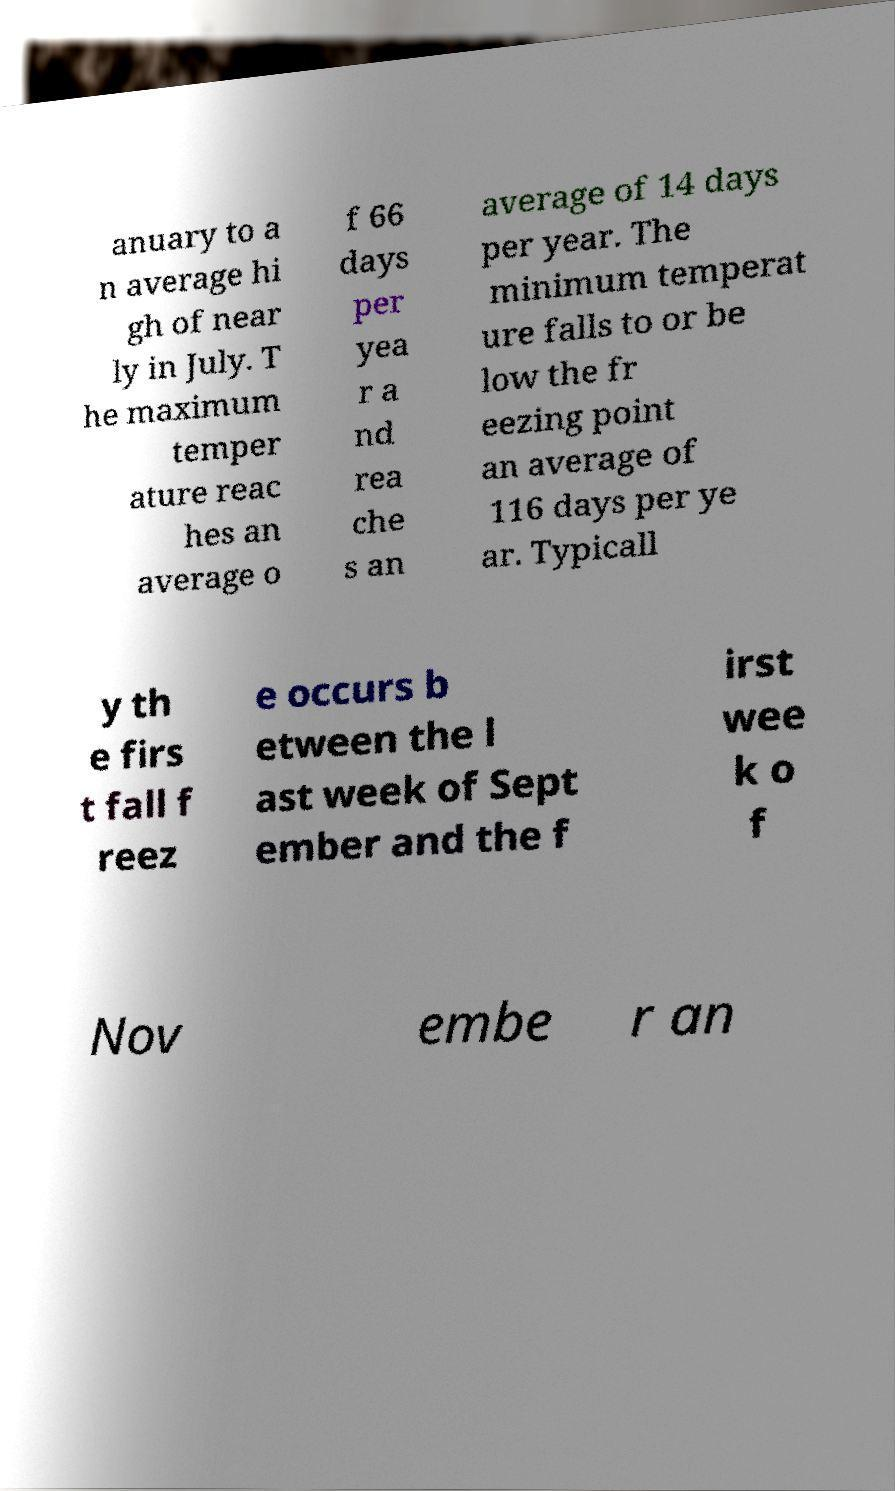For documentation purposes, I need the text within this image transcribed. Could you provide that? anuary to a n average hi gh of near ly in July. T he maximum temper ature reac hes an average o f 66 days per yea r a nd rea che s an average of 14 days per year. The minimum temperat ure falls to or be low the fr eezing point an average of 116 days per ye ar. Typicall y th e firs t fall f reez e occurs b etween the l ast week of Sept ember and the f irst wee k o f Nov embe r an 